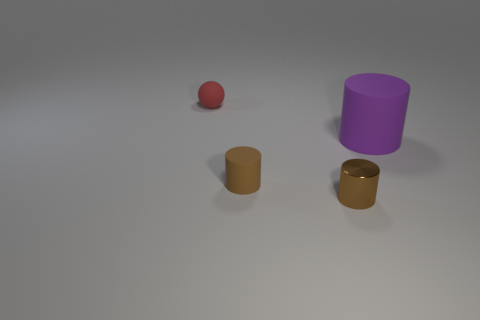Is the number of tiny red matte balls that are right of the sphere greater than the number of rubber spheres in front of the big cylinder?
Your response must be concise. No. Do the small matte cylinder and the matte cylinder that is to the right of the tiny metal cylinder have the same color?
Your response must be concise. No. There is a red sphere that is the same size as the brown rubber cylinder; what material is it?
Give a very brief answer. Rubber. What number of objects are either tiny shiny things or tiny things that are in front of the small red ball?
Ensure brevity in your answer.  2. Do the metal thing and the brown rubber cylinder that is left of the large rubber cylinder have the same size?
Offer a very short reply. Yes. How many cylinders are tiny brown objects or small objects?
Provide a short and direct response. 2. How many rubber objects are both to the left of the purple thing and right of the red ball?
Provide a succinct answer. 1. What number of other things are there of the same color as the metallic object?
Give a very brief answer. 1. There is a small rubber thing that is in front of the big cylinder; what shape is it?
Ensure brevity in your answer.  Cylinder. Does the large thing have the same material as the sphere?
Offer a very short reply. Yes. 